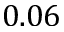<formula> <loc_0><loc_0><loc_500><loc_500>0 . 0 6</formula> 